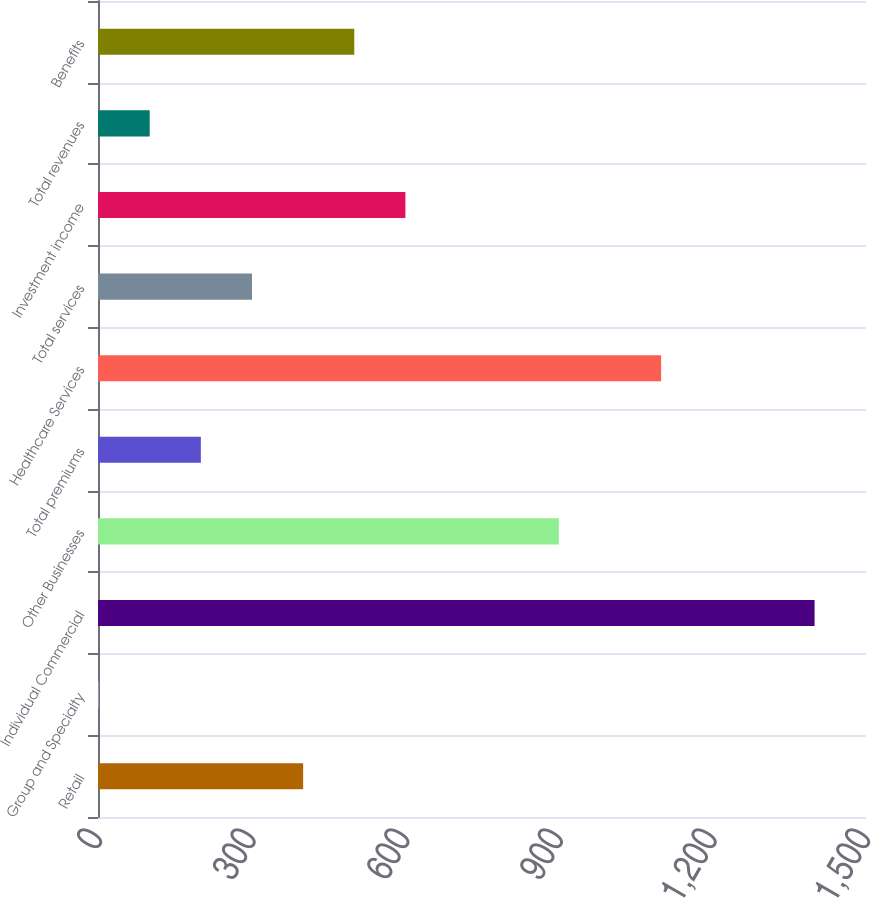Convert chart to OTSL. <chart><loc_0><loc_0><loc_500><loc_500><bar_chart><fcel>Retail<fcel>Group and Specialty<fcel>Individual Commercial<fcel>Other Businesses<fcel>Total premiums<fcel>Healthcare Services<fcel>Total services<fcel>Investment income<fcel>Total revenues<fcel>Benefits<nl><fcel>400.66<fcel>1.1<fcel>1399.56<fcel>900.11<fcel>200.88<fcel>1099.89<fcel>300.77<fcel>600.44<fcel>100.99<fcel>500.55<nl></chart> 